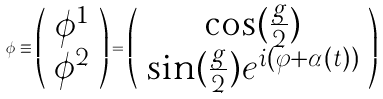<formula> <loc_0><loc_0><loc_500><loc_500>\phi \equiv \left ( \begin{array} { c } \phi ^ { 1 } \\ \phi ^ { 2 } \end{array} \right ) = \left ( \begin{array} { c } \cos ( \frac { g } { 2 } ) \\ \sin ( \frac { g } { 2 } ) e ^ { i ( \varphi + \alpha ( t ) ) } \end{array} \right )</formula> 